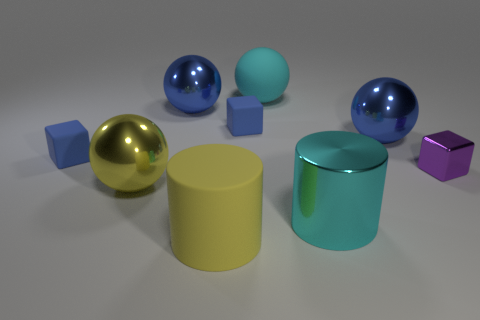Add 1 small brown shiny cylinders. How many objects exist? 10 Subtract all cylinders. How many objects are left? 7 Add 4 metallic blocks. How many metallic blocks are left? 5 Add 8 large yellow things. How many large yellow things exist? 10 Subtract 2 blue blocks. How many objects are left? 7 Subtract all small purple things. Subtract all small things. How many objects are left? 5 